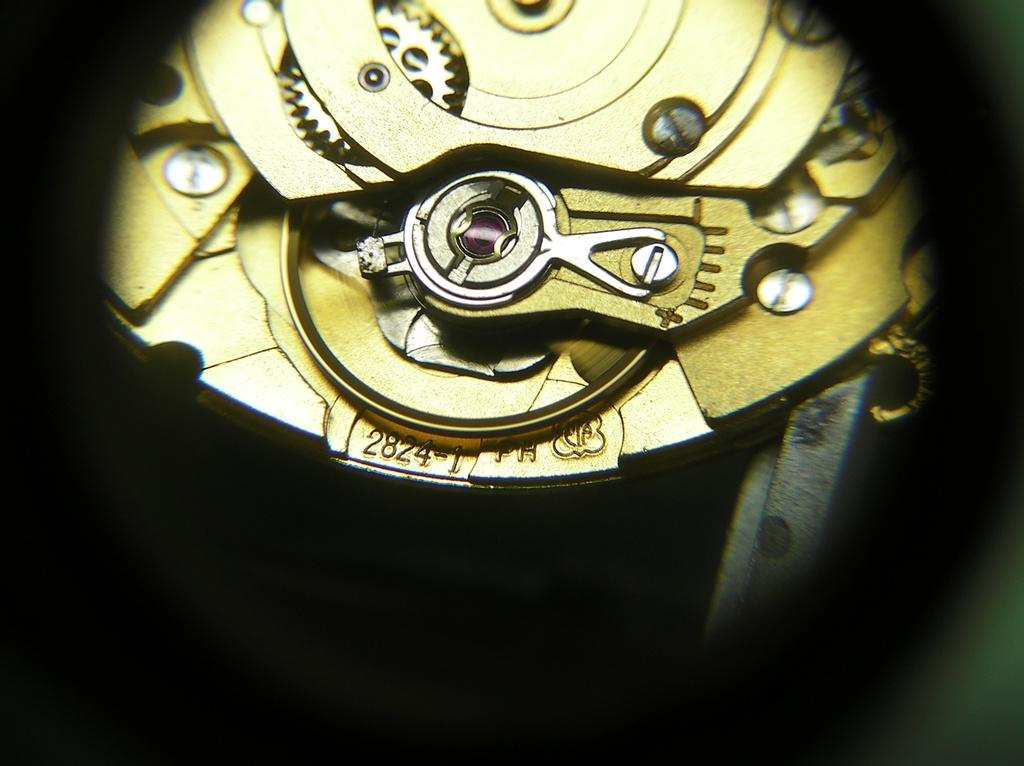<image>
Share a concise interpretation of the image provided. the numbers 2824 are on the gold item 